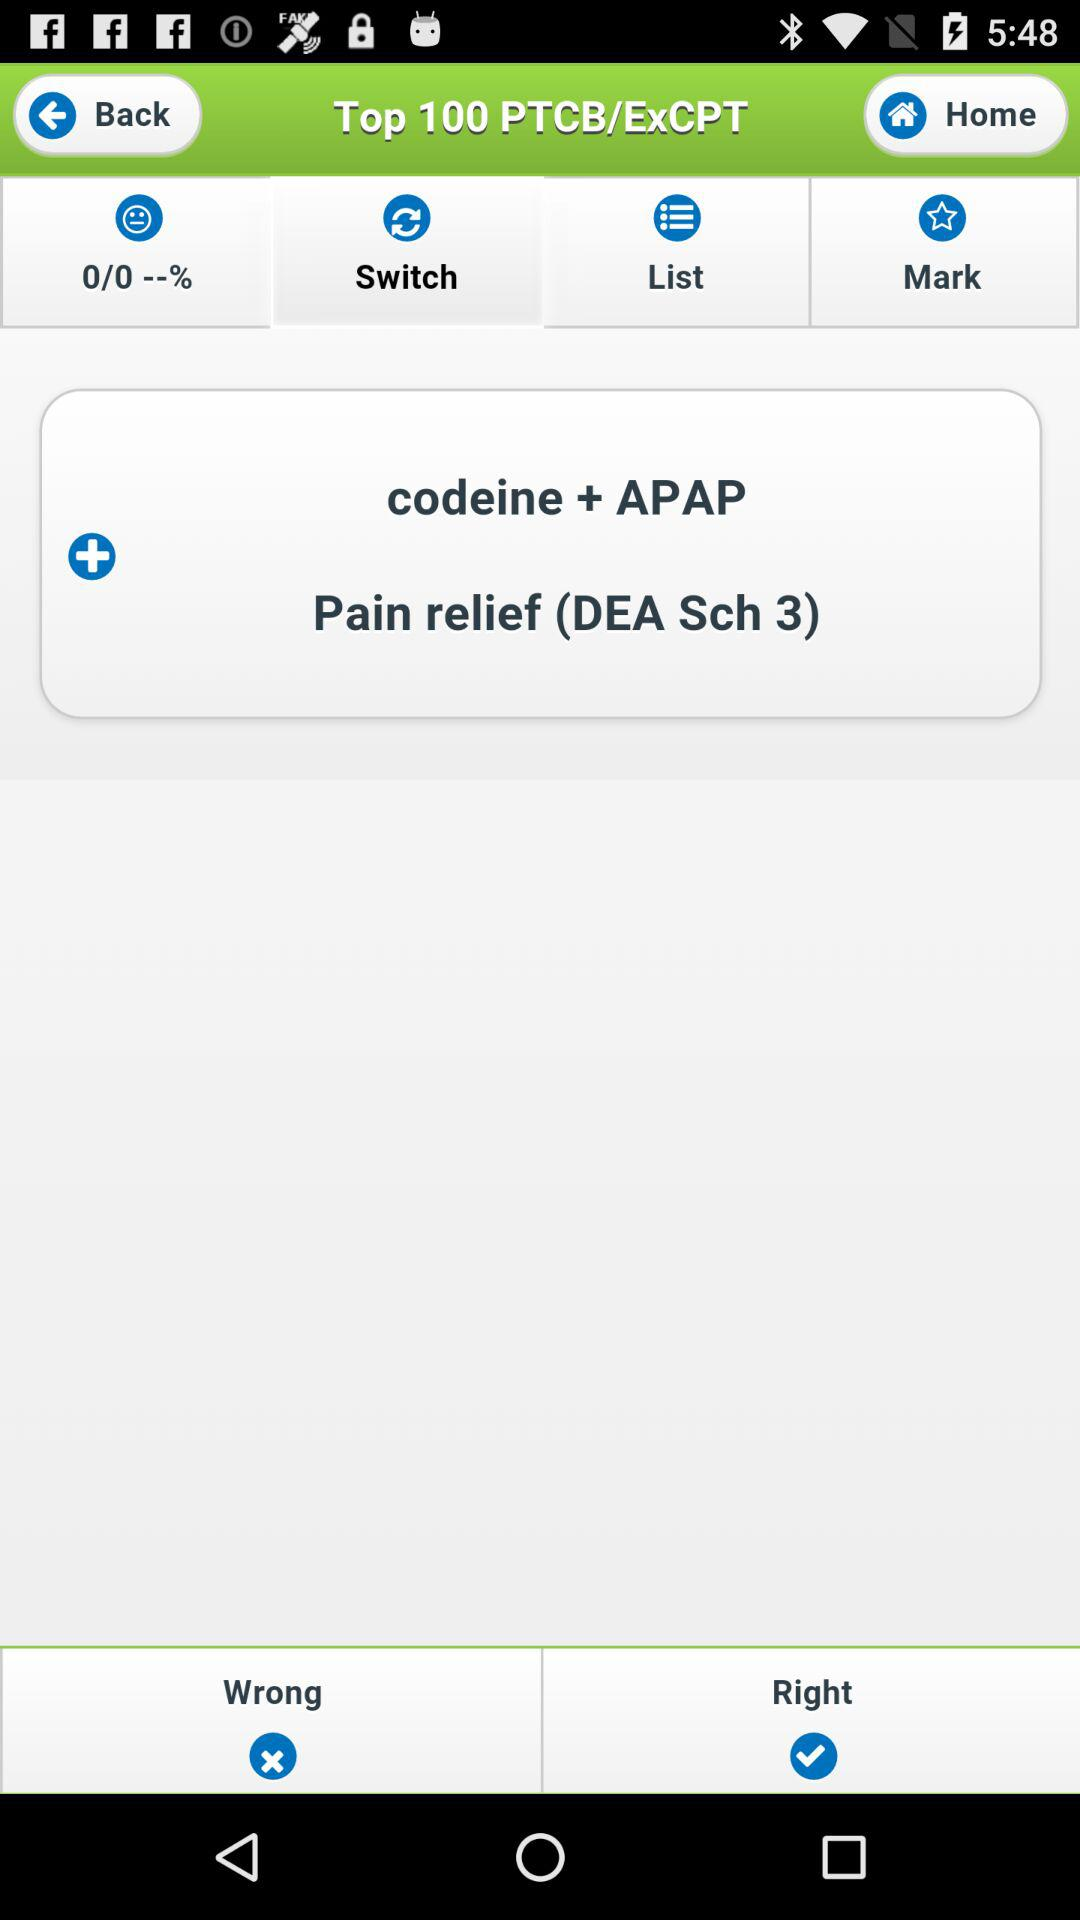Which tab is selected? The selected tab is "Switch". 